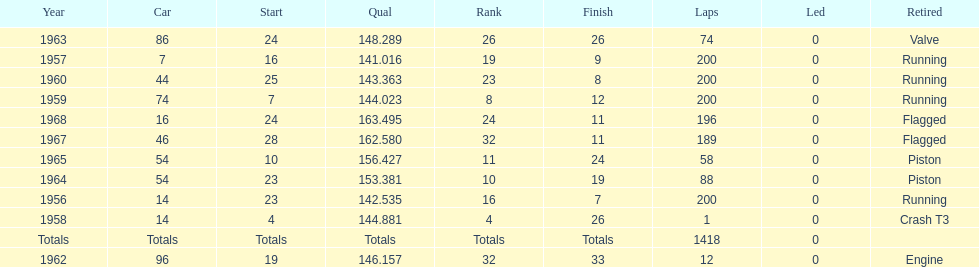What is the larger laps between 1963 or 1968 1968. 